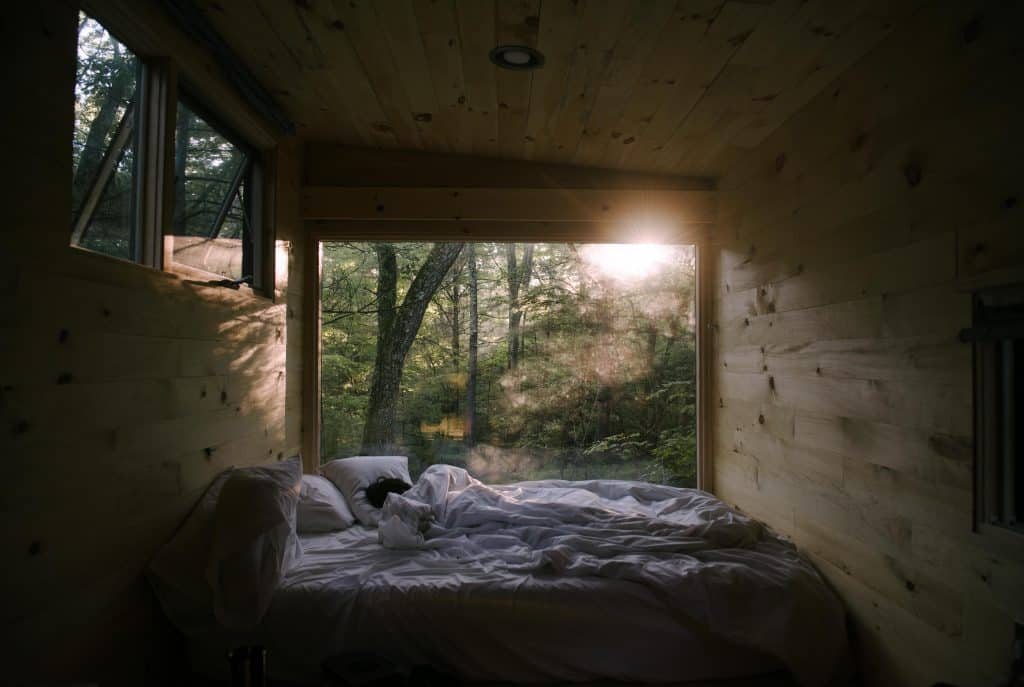How does the current state of the bed affect the overall feel of the space? The bed, with its covers in a relaxed, unmade state, suggests a room that has been lived in and exudes a comfortable, casual vibe. This appearance adds a personal touch to the space, making it feel welcoming and unpretentious. It contrasts with the clean lines and orderliness typically seen in design magazines, expressing a more authentic and approachable atmosphere. 